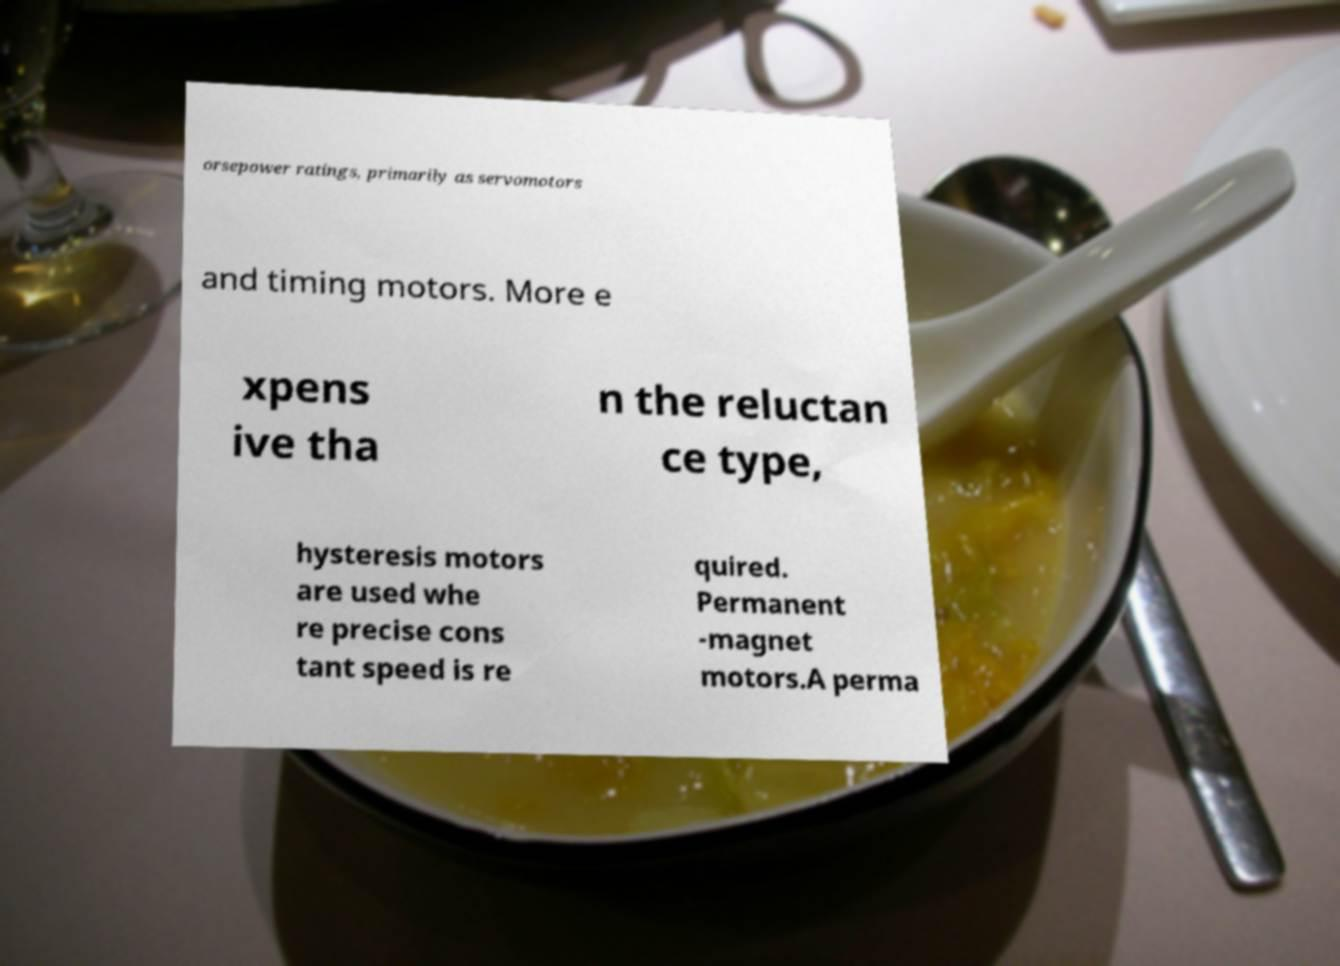Can you accurately transcribe the text from the provided image for me? orsepower ratings, primarily as servomotors and timing motors. More e xpens ive tha n the reluctan ce type, hysteresis motors are used whe re precise cons tant speed is re quired. Permanent -magnet motors.A perma 